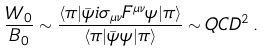Convert formula to latex. <formula><loc_0><loc_0><loc_500><loc_500>\frac { W _ { 0 } } { B _ { 0 } } \sim \frac { \langle \pi | \bar { \psi } i \sigma _ { \mu \nu } F ^ { \mu \nu } \psi | \pi \rangle } { \langle \pi | \bar { \psi } \psi | \pi \rangle } \sim \L Q C D ^ { 2 } \, .</formula> 